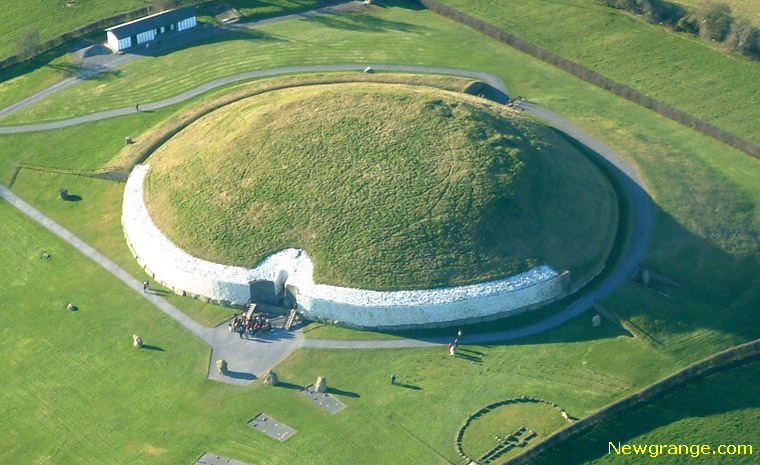Can you describe a day in the life of someone living when Newgrange was built? A day in the life of someone living during the construction of Newgrange would be deeply tied to the rhythms of nature and community. As the morning fog lifted from the Boyne Valley, the people might gather for communal activities, whether it be hunting, farming, or constructing the monument itself. Skilled workers would haul and position massive stones with meticulous care, their efforts coordinated by some form of leader or architect. Others might craft tools, prepare food, or tend to children. Spiritual leaders could conduct rituals, compensating the labor with ceremonies meant to appease gods or ancestors. As the sun set, marking the passage of another day, the people would retreat to their dwellings, sharing stories and meals around the fire, bound by a collective sense of purpose and tradition. 